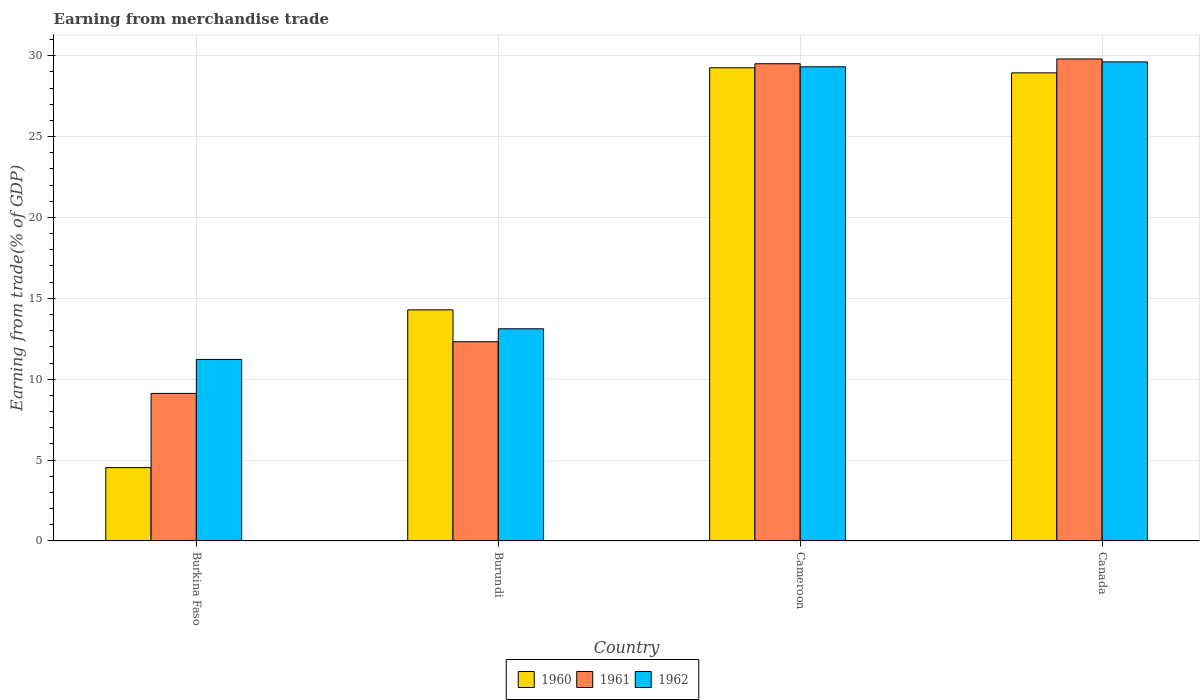Are the number of bars per tick equal to the number of legend labels?
Offer a very short reply. Yes. How many bars are there on the 3rd tick from the left?
Make the answer very short. 3. What is the label of the 1st group of bars from the left?
Give a very brief answer. Burkina Faso. In how many cases, is the number of bars for a given country not equal to the number of legend labels?
Your answer should be very brief. 0. What is the earnings from trade in 1961 in Burkina Faso?
Your answer should be very brief. 9.12. Across all countries, what is the maximum earnings from trade in 1962?
Offer a terse response. 29.62. Across all countries, what is the minimum earnings from trade in 1961?
Give a very brief answer. 9.12. In which country was the earnings from trade in 1962 minimum?
Provide a short and direct response. Burkina Faso. What is the total earnings from trade in 1962 in the graph?
Offer a very short reply. 83.26. What is the difference between the earnings from trade in 1962 in Burkina Faso and that in Canada?
Your answer should be compact. -18.4. What is the difference between the earnings from trade in 1960 in Canada and the earnings from trade in 1961 in Burkina Faso?
Offer a very short reply. 19.82. What is the average earnings from trade in 1962 per country?
Give a very brief answer. 20.82. What is the difference between the earnings from trade of/in 1962 and earnings from trade of/in 1960 in Cameroon?
Provide a short and direct response. 0.06. In how many countries, is the earnings from trade in 1960 greater than 8 %?
Offer a terse response. 3. What is the ratio of the earnings from trade in 1962 in Burkina Faso to that in Cameroon?
Give a very brief answer. 0.38. Is the earnings from trade in 1961 in Burundi less than that in Canada?
Ensure brevity in your answer.  Yes. What is the difference between the highest and the second highest earnings from trade in 1961?
Your answer should be very brief. 17.19. What is the difference between the highest and the lowest earnings from trade in 1961?
Offer a terse response. 20.68. In how many countries, is the earnings from trade in 1962 greater than the average earnings from trade in 1962 taken over all countries?
Make the answer very short. 2. What does the 1st bar from the left in Canada represents?
Give a very brief answer. 1960. Is it the case that in every country, the sum of the earnings from trade in 1961 and earnings from trade in 1962 is greater than the earnings from trade in 1960?
Make the answer very short. Yes. How many bars are there?
Provide a short and direct response. 12. Are all the bars in the graph horizontal?
Ensure brevity in your answer.  No. How many countries are there in the graph?
Provide a short and direct response. 4. What is the difference between two consecutive major ticks on the Y-axis?
Give a very brief answer. 5. Are the values on the major ticks of Y-axis written in scientific E-notation?
Your answer should be compact. No. Does the graph contain grids?
Offer a terse response. Yes. Where does the legend appear in the graph?
Keep it short and to the point. Bottom center. How many legend labels are there?
Give a very brief answer. 3. What is the title of the graph?
Keep it short and to the point. Earning from merchandise trade. Does "2009" appear as one of the legend labels in the graph?
Your response must be concise. No. What is the label or title of the Y-axis?
Your answer should be very brief. Earning from trade(% of GDP). What is the Earning from trade(% of GDP) of 1960 in Burkina Faso?
Provide a short and direct response. 4.53. What is the Earning from trade(% of GDP) of 1961 in Burkina Faso?
Give a very brief answer. 9.12. What is the Earning from trade(% of GDP) of 1962 in Burkina Faso?
Make the answer very short. 11.22. What is the Earning from trade(% of GDP) in 1960 in Burundi?
Your answer should be compact. 14.29. What is the Earning from trade(% of GDP) in 1961 in Burundi?
Give a very brief answer. 12.32. What is the Earning from trade(% of GDP) in 1962 in Burundi?
Provide a succinct answer. 13.11. What is the Earning from trade(% of GDP) of 1960 in Cameroon?
Your response must be concise. 29.25. What is the Earning from trade(% of GDP) of 1961 in Cameroon?
Your answer should be compact. 29.5. What is the Earning from trade(% of GDP) of 1962 in Cameroon?
Provide a succinct answer. 29.31. What is the Earning from trade(% of GDP) in 1960 in Canada?
Your answer should be compact. 28.94. What is the Earning from trade(% of GDP) in 1961 in Canada?
Offer a very short reply. 29.8. What is the Earning from trade(% of GDP) in 1962 in Canada?
Keep it short and to the point. 29.62. Across all countries, what is the maximum Earning from trade(% of GDP) of 1960?
Provide a succinct answer. 29.25. Across all countries, what is the maximum Earning from trade(% of GDP) in 1961?
Your answer should be very brief. 29.8. Across all countries, what is the maximum Earning from trade(% of GDP) of 1962?
Your answer should be very brief. 29.62. Across all countries, what is the minimum Earning from trade(% of GDP) of 1960?
Offer a very short reply. 4.53. Across all countries, what is the minimum Earning from trade(% of GDP) in 1961?
Offer a terse response. 9.12. Across all countries, what is the minimum Earning from trade(% of GDP) of 1962?
Your response must be concise. 11.22. What is the total Earning from trade(% of GDP) in 1960 in the graph?
Your answer should be compact. 77.01. What is the total Earning from trade(% of GDP) in 1961 in the graph?
Give a very brief answer. 80.73. What is the total Earning from trade(% of GDP) in 1962 in the graph?
Give a very brief answer. 83.26. What is the difference between the Earning from trade(% of GDP) of 1960 in Burkina Faso and that in Burundi?
Offer a terse response. -9.75. What is the difference between the Earning from trade(% of GDP) of 1961 in Burkina Faso and that in Burundi?
Ensure brevity in your answer.  -3.19. What is the difference between the Earning from trade(% of GDP) of 1962 in Burkina Faso and that in Burundi?
Make the answer very short. -1.89. What is the difference between the Earning from trade(% of GDP) of 1960 in Burkina Faso and that in Cameroon?
Your answer should be very brief. -24.72. What is the difference between the Earning from trade(% of GDP) in 1961 in Burkina Faso and that in Cameroon?
Your answer should be very brief. -20.38. What is the difference between the Earning from trade(% of GDP) in 1962 in Burkina Faso and that in Cameroon?
Your answer should be compact. -18.09. What is the difference between the Earning from trade(% of GDP) of 1960 in Burkina Faso and that in Canada?
Keep it short and to the point. -24.41. What is the difference between the Earning from trade(% of GDP) in 1961 in Burkina Faso and that in Canada?
Ensure brevity in your answer.  -20.68. What is the difference between the Earning from trade(% of GDP) in 1962 in Burkina Faso and that in Canada?
Offer a terse response. -18.4. What is the difference between the Earning from trade(% of GDP) of 1960 in Burundi and that in Cameroon?
Give a very brief answer. -14.97. What is the difference between the Earning from trade(% of GDP) in 1961 in Burundi and that in Cameroon?
Provide a short and direct response. -17.19. What is the difference between the Earning from trade(% of GDP) of 1962 in Burundi and that in Cameroon?
Keep it short and to the point. -16.2. What is the difference between the Earning from trade(% of GDP) in 1960 in Burundi and that in Canada?
Provide a short and direct response. -14.65. What is the difference between the Earning from trade(% of GDP) in 1961 in Burundi and that in Canada?
Offer a very short reply. -17.48. What is the difference between the Earning from trade(% of GDP) in 1962 in Burundi and that in Canada?
Offer a very short reply. -16.5. What is the difference between the Earning from trade(% of GDP) of 1960 in Cameroon and that in Canada?
Your answer should be very brief. 0.32. What is the difference between the Earning from trade(% of GDP) of 1961 in Cameroon and that in Canada?
Ensure brevity in your answer.  -0.3. What is the difference between the Earning from trade(% of GDP) in 1962 in Cameroon and that in Canada?
Ensure brevity in your answer.  -0.3. What is the difference between the Earning from trade(% of GDP) in 1960 in Burkina Faso and the Earning from trade(% of GDP) in 1961 in Burundi?
Make the answer very short. -7.78. What is the difference between the Earning from trade(% of GDP) in 1960 in Burkina Faso and the Earning from trade(% of GDP) in 1962 in Burundi?
Make the answer very short. -8.58. What is the difference between the Earning from trade(% of GDP) in 1961 in Burkina Faso and the Earning from trade(% of GDP) in 1962 in Burundi?
Make the answer very short. -3.99. What is the difference between the Earning from trade(% of GDP) in 1960 in Burkina Faso and the Earning from trade(% of GDP) in 1961 in Cameroon?
Your response must be concise. -24.97. What is the difference between the Earning from trade(% of GDP) of 1960 in Burkina Faso and the Earning from trade(% of GDP) of 1962 in Cameroon?
Give a very brief answer. -24.78. What is the difference between the Earning from trade(% of GDP) of 1961 in Burkina Faso and the Earning from trade(% of GDP) of 1962 in Cameroon?
Offer a very short reply. -20.19. What is the difference between the Earning from trade(% of GDP) of 1960 in Burkina Faso and the Earning from trade(% of GDP) of 1961 in Canada?
Keep it short and to the point. -25.26. What is the difference between the Earning from trade(% of GDP) of 1960 in Burkina Faso and the Earning from trade(% of GDP) of 1962 in Canada?
Your answer should be compact. -25.08. What is the difference between the Earning from trade(% of GDP) in 1961 in Burkina Faso and the Earning from trade(% of GDP) in 1962 in Canada?
Provide a short and direct response. -20.5. What is the difference between the Earning from trade(% of GDP) of 1960 in Burundi and the Earning from trade(% of GDP) of 1961 in Cameroon?
Keep it short and to the point. -15.22. What is the difference between the Earning from trade(% of GDP) of 1960 in Burundi and the Earning from trade(% of GDP) of 1962 in Cameroon?
Your answer should be very brief. -15.03. What is the difference between the Earning from trade(% of GDP) of 1961 in Burundi and the Earning from trade(% of GDP) of 1962 in Cameroon?
Offer a very short reply. -17. What is the difference between the Earning from trade(% of GDP) of 1960 in Burundi and the Earning from trade(% of GDP) of 1961 in Canada?
Make the answer very short. -15.51. What is the difference between the Earning from trade(% of GDP) in 1960 in Burundi and the Earning from trade(% of GDP) in 1962 in Canada?
Provide a short and direct response. -15.33. What is the difference between the Earning from trade(% of GDP) of 1961 in Burundi and the Earning from trade(% of GDP) of 1962 in Canada?
Ensure brevity in your answer.  -17.3. What is the difference between the Earning from trade(% of GDP) of 1960 in Cameroon and the Earning from trade(% of GDP) of 1961 in Canada?
Make the answer very short. -0.54. What is the difference between the Earning from trade(% of GDP) in 1960 in Cameroon and the Earning from trade(% of GDP) in 1962 in Canada?
Keep it short and to the point. -0.36. What is the difference between the Earning from trade(% of GDP) in 1961 in Cameroon and the Earning from trade(% of GDP) in 1962 in Canada?
Your answer should be very brief. -0.12. What is the average Earning from trade(% of GDP) in 1960 per country?
Provide a succinct answer. 19.25. What is the average Earning from trade(% of GDP) in 1961 per country?
Ensure brevity in your answer.  20.18. What is the average Earning from trade(% of GDP) in 1962 per country?
Keep it short and to the point. 20.82. What is the difference between the Earning from trade(% of GDP) in 1960 and Earning from trade(% of GDP) in 1961 in Burkina Faso?
Keep it short and to the point. -4.59. What is the difference between the Earning from trade(% of GDP) of 1960 and Earning from trade(% of GDP) of 1962 in Burkina Faso?
Offer a terse response. -6.69. What is the difference between the Earning from trade(% of GDP) in 1961 and Earning from trade(% of GDP) in 1962 in Burkina Faso?
Your answer should be compact. -2.1. What is the difference between the Earning from trade(% of GDP) in 1960 and Earning from trade(% of GDP) in 1961 in Burundi?
Offer a very short reply. 1.97. What is the difference between the Earning from trade(% of GDP) of 1960 and Earning from trade(% of GDP) of 1962 in Burundi?
Offer a very short reply. 1.17. What is the difference between the Earning from trade(% of GDP) in 1961 and Earning from trade(% of GDP) in 1962 in Burundi?
Provide a succinct answer. -0.8. What is the difference between the Earning from trade(% of GDP) in 1960 and Earning from trade(% of GDP) in 1961 in Cameroon?
Keep it short and to the point. -0.25. What is the difference between the Earning from trade(% of GDP) in 1960 and Earning from trade(% of GDP) in 1962 in Cameroon?
Offer a very short reply. -0.06. What is the difference between the Earning from trade(% of GDP) of 1961 and Earning from trade(% of GDP) of 1962 in Cameroon?
Your answer should be compact. 0.19. What is the difference between the Earning from trade(% of GDP) of 1960 and Earning from trade(% of GDP) of 1961 in Canada?
Make the answer very short. -0.86. What is the difference between the Earning from trade(% of GDP) in 1960 and Earning from trade(% of GDP) in 1962 in Canada?
Offer a very short reply. -0.68. What is the difference between the Earning from trade(% of GDP) in 1961 and Earning from trade(% of GDP) in 1962 in Canada?
Offer a very short reply. 0.18. What is the ratio of the Earning from trade(% of GDP) in 1960 in Burkina Faso to that in Burundi?
Give a very brief answer. 0.32. What is the ratio of the Earning from trade(% of GDP) of 1961 in Burkina Faso to that in Burundi?
Your answer should be compact. 0.74. What is the ratio of the Earning from trade(% of GDP) of 1962 in Burkina Faso to that in Burundi?
Your response must be concise. 0.86. What is the ratio of the Earning from trade(% of GDP) in 1960 in Burkina Faso to that in Cameroon?
Make the answer very short. 0.15. What is the ratio of the Earning from trade(% of GDP) in 1961 in Burkina Faso to that in Cameroon?
Your answer should be compact. 0.31. What is the ratio of the Earning from trade(% of GDP) in 1962 in Burkina Faso to that in Cameroon?
Offer a very short reply. 0.38. What is the ratio of the Earning from trade(% of GDP) in 1960 in Burkina Faso to that in Canada?
Provide a succinct answer. 0.16. What is the ratio of the Earning from trade(% of GDP) of 1961 in Burkina Faso to that in Canada?
Offer a very short reply. 0.31. What is the ratio of the Earning from trade(% of GDP) in 1962 in Burkina Faso to that in Canada?
Your response must be concise. 0.38. What is the ratio of the Earning from trade(% of GDP) in 1960 in Burundi to that in Cameroon?
Provide a short and direct response. 0.49. What is the ratio of the Earning from trade(% of GDP) of 1961 in Burundi to that in Cameroon?
Your answer should be very brief. 0.42. What is the ratio of the Earning from trade(% of GDP) of 1962 in Burundi to that in Cameroon?
Provide a succinct answer. 0.45. What is the ratio of the Earning from trade(% of GDP) in 1960 in Burundi to that in Canada?
Offer a terse response. 0.49. What is the ratio of the Earning from trade(% of GDP) of 1961 in Burundi to that in Canada?
Provide a succinct answer. 0.41. What is the ratio of the Earning from trade(% of GDP) of 1962 in Burundi to that in Canada?
Your answer should be very brief. 0.44. What is the ratio of the Earning from trade(% of GDP) in 1960 in Cameroon to that in Canada?
Your response must be concise. 1.01. What is the ratio of the Earning from trade(% of GDP) of 1962 in Cameroon to that in Canada?
Keep it short and to the point. 0.99. What is the difference between the highest and the second highest Earning from trade(% of GDP) in 1960?
Make the answer very short. 0.32. What is the difference between the highest and the second highest Earning from trade(% of GDP) of 1961?
Offer a very short reply. 0.3. What is the difference between the highest and the second highest Earning from trade(% of GDP) in 1962?
Your answer should be very brief. 0.3. What is the difference between the highest and the lowest Earning from trade(% of GDP) in 1960?
Your answer should be very brief. 24.72. What is the difference between the highest and the lowest Earning from trade(% of GDP) of 1961?
Ensure brevity in your answer.  20.68. What is the difference between the highest and the lowest Earning from trade(% of GDP) in 1962?
Keep it short and to the point. 18.4. 